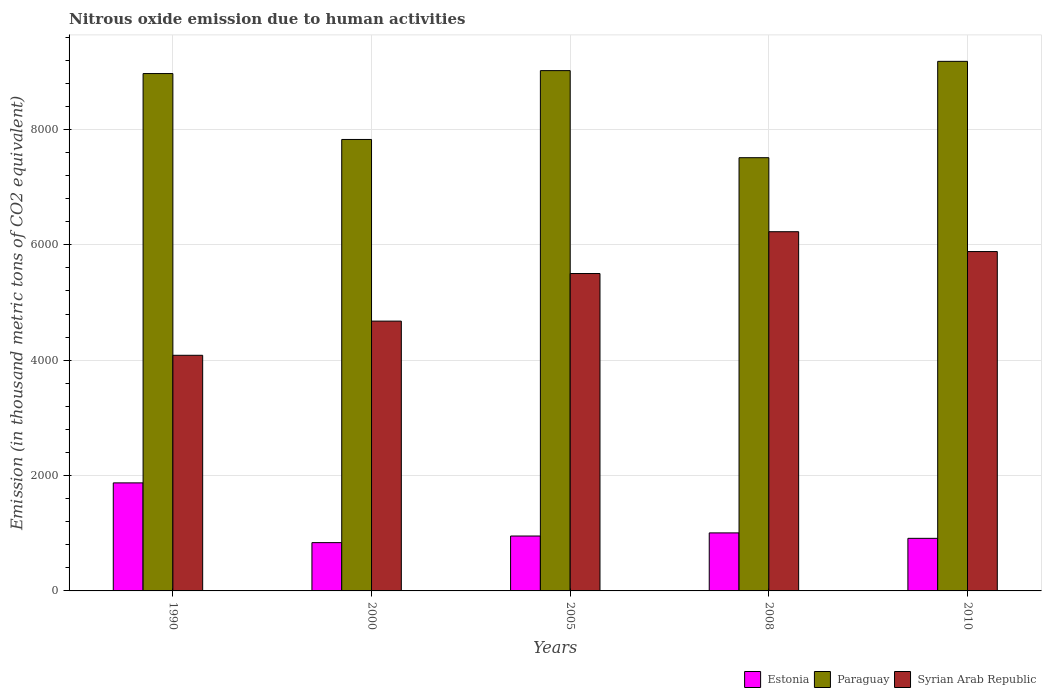How many different coloured bars are there?
Offer a very short reply. 3. How many bars are there on the 3rd tick from the left?
Your response must be concise. 3. How many bars are there on the 2nd tick from the right?
Provide a short and direct response. 3. What is the label of the 3rd group of bars from the left?
Ensure brevity in your answer.  2005. In how many cases, is the number of bars for a given year not equal to the number of legend labels?
Offer a very short reply. 0. What is the amount of nitrous oxide emitted in Syrian Arab Republic in 2000?
Your answer should be compact. 4677.3. Across all years, what is the maximum amount of nitrous oxide emitted in Estonia?
Make the answer very short. 1872.9. Across all years, what is the minimum amount of nitrous oxide emitted in Paraguay?
Your answer should be very brief. 7510.2. In which year was the amount of nitrous oxide emitted in Estonia maximum?
Make the answer very short. 1990. In which year was the amount of nitrous oxide emitted in Estonia minimum?
Provide a short and direct response. 2000. What is the total amount of nitrous oxide emitted in Estonia in the graph?
Offer a terse response. 5579.2. What is the difference between the amount of nitrous oxide emitted in Estonia in 1990 and that in 2000?
Provide a succinct answer. 1035.9. What is the difference between the amount of nitrous oxide emitted in Paraguay in 2008 and the amount of nitrous oxide emitted in Estonia in 1990?
Offer a terse response. 5637.3. What is the average amount of nitrous oxide emitted in Estonia per year?
Provide a succinct answer. 1115.84. In the year 1990, what is the difference between the amount of nitrous oxide emitted in Syrian Arab Republic and amount of nitrous oxide emitted in Estonia?
Your answer should be compact. 2211.9. What is the ratio of the amount of nitrous oxide emitted in Paraguay in 2005 to that in 2008?
Offer a terse response. 1.2. Is the amount of nitrous oxide emitted in Estonia in 2005 less than that in 2010?
Keep it short and to the point. No. What is the difference between the highest and the second highest amount of nitrous oxide emitted in Estonia?
Keep it short and to the point. 867. What is the difference between the highest and the lowest amount of nitrous oxide emitted in Estonia?
Keep it short and to the point. 1035.9. In how many years, is the amount of nitrous oxide emitted in Syrian Arab Republic greater than the average amount of nitrous oxide emitted in Syrian Arab Republic taken over all years?
Your answer should be compact. 3. Is the sum of the amount of nitrous oxide emitted in Paraguay in 2005 and 2008 greater than the maximum amount of nitrous oxide emitted in Syrian Arab Republic across all years?
Provide a succinct answer. Yes. What does the 1st bar from the left in 2005 represents?
Your response must be concise. Estonia. What does the 2nd bar from the right in 1990 represents?
Make the answer very short. Paraguay. How many bars are there?
Ensure brevity in your answer.  15. How many years are there in the graph?
Keep it short and to the point. 5. What is the difference between two consecutive major ticks on the Y-axis?
Your answer should be compact. 2000. Does the graph contain any zero values?
Provide a succinct answer. No. Where does the legend appear in the graph?
Provide a short and direct response. Bottom right. How are the legend labels stacked?
Ensure brevity in your answer.  Horizontal. What is the title of the graph?
Your answer should be compact. Nitrous oxide emission due to human activities. What is the label or title of the Y-axis?
Offer a very short reply. Emission (in thousand metric tons of CO2 equivalent). What is the Emission (in thousand metric tons of CO2 equivalent) of Estonia in 1990?
Give a very brief answer. 1872.9. What is the Emission (in thousand metric tons of CO2 equivalent) of Paraguay in 1990?
Give a very brief answer. 8968.7. What is the Emission (in thousand metric tons of CO2 equivalent) of Syrian Arab Republic in 1990?
Offer a terse response. 4084.8. What is the Emission (in thousand metric tons of CO2 equivalent) of Estonia in 2000?
Provide a short and direct response. 837. What is the Emission (in thousand metric tons of CO2 equivalent) of Paraguay in 2000?
Your answer should be very brief. 7826.3. What is the Emission (in thousand metric tons of CO2 equivalent) of Syrian Arab Republic in 2000?
Your answer should be compact. 4677.3. What is the Emission (in thousand metric tons of CO2 equivalent) of Estonia in 2005?
Your answer should be very brief. 951.7. What is the Emission (in thousand metric tons of CO2 equivalent) of Paraguay in 2005?
Make the answer very short. 9019.7. What is the Emission (in thousand metric tons of CO2 equivalent) in Syrian Arab Republic in 2005?
Offer a terse response. 5502.2. What is the Emission (in thousand metric tons of CO2 equivalent) in Estonia in 2008?
Offer a terse response. 1005.9. What is the Emission (in thousand metric tons of CO2 equivalent) in Paraguay in 2008?
Provide a short and direct response. 7510.2. What is the Emission (in thousand metric tons of CO2 equivalent) in Syrian Arab Republic in 2008?
Offer a very short reply. 6227.1. What is the Emission (in thousand metric tons of CO2 equivalent) of Estonia in 2010?
Make the answer very short. 911.7. What is the Emission (in thousand metric tons of CO2 equivalent) in Paraguay in 2010?
Provide a short and direct response. 9180.3. What is the Emission (in thousand metric tons of CO2 equivalent) of Syrian Arab Republic in 2010?
Your answer should be very brief. 5883.1. Across all years, what is the maximum Emission (in thousand metric tons of CO2 equivalent) of Estonia?
Your answer should be very brief. 1872.9. Across all years, what is the maximum Emission (in thousand metric tons of CO2 equivalent) in Paraguay?
Your response must be concise. 9180.3. Across all years, what is the maximum Emission (in thousand metric tons of CO2 equivalent) in Syrian Arab Republic?
Give a very brief answer. 6227.1. Across all years, what is the minimum Emission (in thousand metric tons of CO2 equivalent) in Estonia?
Your answer should be very brief. 837. Across all years, what is the minimum Emission (in thousand metric tons of CO2 equivalent) of Paraguay?
Your answer should be very brief. 7510.2. Across all years, what is the minimum Emission (in thousand metric tons of CO2 equivalent) of Syrian Arab Republic?
Offer a terse response. 4084.8. What is the total Emission (in thousand metric tons of CO2 equivalent) of Estonia in the graph?
Ensure brevity in your answer.  5579.2. What is the total Emission (in thousand metric tons of CO2 equivalent) in Paraguay in the graph?
Ensure brevity in your answer.  4.25e+04. What is the total Emission (in thousand metric tons of CO2 equivalent) in Syrian Arab Republic in the graph?
Offer a very short reply. 2.64e+04. What is the difference between the Emission (in thousand metric tons of CO2 equivalent) in Estonia in 1990 and that in 2000?
Offer a terse response. 1035.9. What is the difference between the Emission (in thousand metric tons of CO2 equivalent) in Paraguay in 1990 and that in 2000?
Your response must be concise. 1142.4. What is the difference between the Emission (in thousand metric tons of CO2 equivalent) of Syrian Arab Republic in 1990 and that in 2000?
Ensure brevity in your answer.  -592.5. What is the difference between the Emission (in thousand metric tons of CO2 equivalent) in Estonia in 1990 and that in 2005?
Keep it short and to the point. 921.2. What is the difference between the Emission (in thousand metric tons of CO2 equivalent) of Paraguay in 1990 and that in 2005?
Your answer should be very brief. -51. What is the difference between the Emission (in thousand metric tons of CO2 equivalent) in Syrian Arab Republic in 1990 and that in 2005?
Your answer should be compact. -1417.4. What is the difference between the Emission (in thousand metric tons of CO2 equivalent) in Estonia in 1990 and that in 2008?
Your response must be concise. 867. What is the difference between the Emission (in thousand metric tons of CO2 equivalent) of Paraguay in 1990 and that in 2008?
Ensure brevity in your answer.  1458.5. What is the difference between the Emission (in thousand metric tons of CO2 equivalent) of Syrian Arab Republic in 1990 and that in 2008?
Provide a succinct answer. -2142.3. What is the difference between the Emission (in thousand metric tons of CO2 equivalent) of Estonia in 1990 and that in 2010?
Provide a succinct answer. 961.2. What is the difference between the Emission (in thousand metric tons of CO2 equivalent) in Paraguay in 1990 and that in 2010?
Your answer should be compact. -211.6. What is the difference between the Emission (in thousand metric tons of CO2 equivalent) in Syrian Arab Republic in 1990 and that in 2010?
Make the answer very short. -1798.3. What is the difference between the Emission (in thousand metric tons of CO2 equivalent) of Estonia in 2000 and that in 2005?
Make the answer very short. -114.7. What is the difference between the Emission (in thousand metric tons of CO2 equivalent) of Paraguay in 2000 and that in 2005?
Offer a terse response. -1193.4. What is the difference between the Emission (in thousand metric tons of CO2 equivalent) of Syrian Arab Republic in 2000 and that in 2005?
Provide a short and direct response. -824.9. What is the difference between the Emission (in thousand metric tons of CO2 equivalent) of Estonia in 2000 and that in 2008?
Ensure brevity in your answer.  -168.9. What is the difference between the Emission (in thousand metric tons of CO2 equivalent) in Paraguay in 2000 and that in 2008?
Give a very brief answer. 316.1. What is the difference between the Emission (in thousand metric tons of CO2 equivalent) of Syrian Arab Republic in 2000 and that in 2008?
Provide a succinct answer. -1549.8. What is the difference between the Emission (in thousand metric tons of CO2 equivalent) of Estonia in 2000 and that in 2010?
Your answer should be compact. -74.7. What is the difference between the Emission (in thousand metric tons of CO2 equivalent) in Paraguay in 2000 and that in 2010?
Offer a very short reply. -1354. What is the difference between the Emission (in thousand metric tons of CO2 equivalent) in Syrian Arab Republic in 2000 and that in 2010?
Provide a succinct answer. -1205.8. What is the difference between the Emission (in thousand metric tons of CO2 equivalent) of Estonia in 2005 and that in 2008?
Keep it short and to the point. -54.2. What is the difference between the Emission (in thousand metric tons of CO2 equivalent) in Paraguay in 2005 and that in 2008?
Your answer should be compact. 1509.5. What is the difference between the Emission (in thousand metric tons of CO2 equivalent) in Syrian Arab Republic in 2005 and that in 2008?
Your answer should be compact. -724.9. What is the difference between the Emission (in thousand metric tons of CO2 equivalent) in Estonia in 2005 and that in 2010?
Provide a short and direct response. 40. What is the difference between the Emission (in thousand metric tons of CO2 equivalent) of Paraguay in 2005 and that in 2010?
Offer a very short reply. -160.6. What is the difference between the Emission (in thousand metric tons of CO2 equivalent) in Syrian Arab Republic in 2005 and that in 2010?
Provide a succinct answer. -380.9. What is the difference between the Emission (in thousand metric tons of CO2 equivalent) in Estonia in 2008 and that in 2010?
Offer a terse response. 94.2. What is the difference between the Emission (in thousand metric tons of CO2 equivalent) in Paraguay in 2008 and that in 2010?
Your answer should be very brief. -1670.1. What is the difference between the Emission (in thousand metric tons of CO2 equivalent) in Syrian Arab Republic in 2008 and that in 2010?
Offer a terse response. 344. What is the difference between the Emission (in thousand metric tons of CO2 equivalent) of Estonia in 1990 and the Emission (in thousand metric tons of CO2 equivalent) of Paraguay in 2000?
Provide a short and direct response. -5953.4. What is the difference between the Emission (in thousand metric tons of CO2 equivalent) of Estonia in 1990 and the Emission (in thousand metric tons of CO2 equivalent) of Syrian Arab Republic in 2000?
Your answer should be very brief. -2804.4. What is the difference between the Emission (in thousand metric tons of CO2 equivalent) in Paraguay in 1990 and the Emission (in thousand metric tons of CO2 equivalent) in Syrian Arab Republic in 2000?
Provide a succinct answer. 4291.4. What is the difference between the Emission (in thousand metric tons of CO2 equivalent) in Estonia in 1990 and the Emission (in thousand metric tons of CO2 equivalent) in Paraguay in 2005?
Your response must be concise. -7146.8. What is the difference between the Emission (in thousand metric tons of CO2 equivalent) of Estonia in 1990 and the Emission (in thousand metric tons of CO2 equivalent) of Syrian Arab Republic in 2005?
Your response must be concise. -3629.3. What is the difference between the Emission (in thousand metric tons of CO2 equivalent) in Paraguay in 1990 and the Emission (in thousand metric tons of CO2 equivalent) in Syrian Arab Republic in 2005?
Offer a terse response. 3466.5. What is the difference between the Emission (in thousand metric tons of CO2 equivalent) of Estonia in 1990 and the Emission (in thousand metric tons of CO2 equivalent) of Paraguay in 2008?
Offer a very short reply. -5637.3. What is the difference between the Emission (in thousand metric tons of CO2 equivalent) in Estonia in 1990 and the Emission (in thousand metric tons of CO2 equivalent) in Syrian Arab Republic in 2008?
Provide a succinct answer. -4354.2. What is the difference between the Emission (in thousand metric tons of CO2 equivalent) of Paraguay in 1990 and the Emission (in thousand metric tons of CO2 equivalent) of Syrian Arab Republic in 2008?
Provide a short and direct response. 2741.6. What is the difference between the Emission (in thousand metric tons of CO2 equivalent) of Estonia in 1990 and the Emission (in thousand metric tons of CO2 equivalent) of Paraguay in 2010?
Provide a short and direct response. -7307.4. What is the difference between the Emission (in thousand metric tons of CO2 equivalent) in Estonia in 1990 and the Emission (in thousand metric tons of CO2 equivalent) in Syrian Arab Republic in 2010?
Keep it short and to the point. -4010.2. What is the difference between the Emission (in thousand metric tons of CO2 equivalent) of Paraguay in 1990 and the Emission (in thousand metric tons of CO2 equivalent) of Syrian Arab Republic in 2010?
Ensure brevity in your answer.  3085.6. What is the difference between the Emission (in thousand metric tons of CO2 equivalent) of Estonia in 2000 and the Emission (in thousand metric tons of CO2 equivalent) of Paraguay in 2005?
Your answer should be compact. -8182.7. What is the difference between the Emission (in thousand metric tons of CO2 equivalent) in Estonia in 2000 and the Emission (in thousand metric tons of CO2 equivalent) in Syrian Arab Republic in 2005?
Keep it short and to the point. -4665.2. What is the difference between the Emission (in thousand metric tons of CO2 equivalent) in Paraguay in 2000 and the Emission (in thousand metric tons of CO2 equivalent) in Syrian Arab Republic in 2005?
Give a very brief answer. 2324.1. What is the difference between the Emission (in thousand metric tons of CO2 equivalent) in Estonia in 2000 and the Emission (in thousand metric tons of CO2 equivalent) in Paraguay in 2008?
Ensure brevity in your answer.  -6673.2. What is the difference between the Emission (in thousand metric tons of CO2 equivalent) in Estonia in 2000 and the Emission (in thousand metric tons of CO2 equivalent) in Syrian Arab Republic in 2008?
Keep it short and to the point. -5390.1. What is the difference between the Emission (in thousand metric tons of CO2 equivalent) of Paraguay in 2000 and the Emission (in thousand metric tons of CO2 equivalent) of Syrian Arab Republic in 2008?
Provide a short and direct response. 1599.2. What is the difference between the Emission (in thousand metric tons of CO2 equivalent) in Estonia in 2000 and the Emission (in thousand metric tons of CO2 equivalent) in Paraguay in 2010?
Give a very brief answer. -8343.3. What is the difference between the Emission (in thousand metric tons of CO2 equivalent) in Estonia in 2000 and the Emission (in thousand metric tons of CO2 equivalent) in Syrian Arab Republic in 2010?
Your answer should be compact. -5046.1. What is the difference between the Emission (in thousand metric tons of CO2 equivalent) of Paraguay in 2000 and the Emission (in thousand metric tons of CO2 equivalent) of Syrian Arab Republic in 2010?
Your answer should be very brief. 1943.2. What is the difference between the Emission (in thousand metric tons of CO2 equivalent) of Estonia in 2005 and the Emission (in thousand metric tons of CO2 equivalent) of Paraguay in 2008?
Offer a terse response. -6558.5. What is the difference between the Emission (in thousand metric tons of CO2 equivalent) in Estonia in 2005 and the Emission (in thousand metric tons of CO2 equivalent) in Syrian Arab Republic in 2008?
Keep it short and to the point. -5275.4. What is the difference between the Emission (in thousand metric tons of CO2 equivalent) in Paraguay in 2005 and the Emission (in thousand metric tons of CO2 equivalent) in Syrian Arab Republic in 2008?
Your answer should be compact. 2792.6. What is the difference between the Emission (in thousand metric tons of CO2 equivalent) of Estonia in 2005 and the Emission (in thousand metric tons of CO2 equivalent) of Paraguay in 2010?
Offer a very short reply. -8228.6. What is the difference between the Emission (in thousand metric tons of CO2 equivalent) in Estonia in 2005 and the Emission (in thousand metric tons of CO2 equivalent) in Syrian Arab Republic in 2010?
Give a very brief answer. -4931.4. What is the difference between the Emission (in thousand metric tons of CO2 equivalent) of Paraguay in 2005 and the Emission (in thousand metric tons of CO2 equivalent) of Syrian Arab Republic in 2010?
Offer a terse response. 3136.6. What is the difference between the Emission (in thousand metric tons of CO2 equivalent) of Estonia in 2008 and the Emission (in thousand metric tons of CO2 equivalent) of Paraguay in 2010?
Provide a short and direct response. -8174.4. What is the difference between the Emission (in thousand metric tons of CO2 equivalent) of Estonia in 2008 and the Emission (in thousand metric tons of CO2 equivalent) of Syrian Arab Republic in 2010?
Your answer should be very brief. -4877.2. What is the difference between the Emission (in thousand metric tons of CO2 equivalent) in Paraguay in 2008 and the Emission (in thousand metric tons of CO2 equivalent) in Syrian Arab Republic in 2010?
Offer a very short reply. 1627.1. What is the average Emission (in thousand metric tons of CO2 equivalent) of Estonia per year?
Make the answer very short. 1115.84. What is the average Emission (in thousand metric tons of CO2 equivalent) in Paraguay per year?
Offer a terse response. 8501.04. What is the average Emission (in thousand metric tons of CO2 equivalent) in Syrian Arab Republic per year?
Your response must be concise. 5274.9. In the year 1990, what is the difference between the Emission (in thousand metric tons of CO2 equivalent) of Estonia and Emission (in thousand metric tons of CO2 equivalent) of Paraguay?
Your answer should be compact. -7095.8. In the year 1990, what is the difference between the Emission (in thousand metric tons of CO2 equivalent) of Estonia and Emission (in thousand metric tons of CO2 equivalent) of Syrian Arab Republic?
Keep it short and to the point. -2211.9. In the year 1990, what is the difference between the Emission (in thousand metric tons of CO2 equivalent) in Paraguay and Emission (in thousand metric tons of CO2 equivalent) in Syrian Arab Republic?
Offer a terse response. 4883.9. In the year 2000, what is the difference between the Emission (in thousand metric tons of CO2 equivalent) in Estonia and Emission (in thousand metric tons of CO2 equivalent) in Paraguay?
Give a very brief answer. -6989.3. In the year 2000, what is the difference between the Emission (in thousand metric tons of CO2 equivalent) of Estonia and Emission (in thousand metric tons of CO2 equivalent) of Syrian Arab Republic?
Your response must be concise. -3840.3. In the year 2000, what is the difference between the Emission (in thousand metric tons of CO2 equivalent) of Paraguay and Emission (in thousand metric tons of CO2 equivalent) of Syrian Arab Republic?
Provide a short and direct response. 3149. In the year 2005, what is the difference between the Emission (in thousand metric tons of CO2 equivalent) of Estonia and Emission (in thousand metric tons of CO2 equivalent) of Paraguay?
Offer a terse response. -8068. In the year 2005, what is the difference between the Emission (in thousand metric tons of CO2 equivalent) of Estonia and Emission (in thousand metric tons of CO2 equivalent) of Syrian Arab Republic?
Your answer should be very brief. -4550.5. In the year 2005, what is the difference between the Emission (in thousand metric tons of CO2 equivalent) in Paraguay and Emission (in thousand metric tons of CO2 equivalent) in Syrian Arab Republic?
Make the answer very short. 3517.5. In the year 2008, what is the difference between the Emission (in thousand metric tons of CO2 equivalent) of Estonia and Emission (in thousand metric tons of CO2 equivalent) of Paraguay?
Your answer should be compact. -6504.3. In the year 2008, what is the difference between the Emission (in thousand metric tons of CO2 equivalent) of Estonia and Emission (in thousand metric tons of CO2 equivalent) of Syrian Arab Republic?
Your answer should be compact. -5221.2. In the year 2008, what is the difference between the Emission (in thousand metric tons of CO2 equivalent) in Paraguay and Emission (in thousand metric tons of CO2 equivalent) in Syrian Arab Republic?
Ensure brevity in your answer.  1283.1. In the year 2010, what is the difference between the Emission (in thousand metric tons of CO2 equivalent) in Estonia and Emission (in thousand metric tons of CO2 equivalent) in Paraguay?
Give a very brief answer. -8268.6. In the year 2010, what is the difference between the Emission (in thousand metric tons of CO2 equivalent) in Estonia and Emission (in thousand metric tons of CO2 equivalent) in Syrian Arab Republic?
Your answer should be very brief. -4971.4. In the year 2010, what is the difference between the Emission (in thousand metric tons of CO2 equivalent) in Paraguay and Emission (in thousand metric tons of CO2 equivalent) in Syrian Arab Republic?
Ensure brevity in your answer.  3297.2. What is the ratio of the Emission (in thousand metric tons of CO2 equivalent) in Estonia in 1990 to that in 2000?
Provide a succinct answer. 2.24. What is the ratio of the Emission (in thousand metric tons of CO2 equivalent) in Paraguay in 1990 to that in 2000?
Ensure brevity in your answer.  1.15. What is the ratio of the Emission (in thousand metric tons of CO2 equivalent) in Syrian Arab Republic in 1990 to that in 2000?
Your response must be concise. 0.87. What is the ratio of the Emission (in thousand metric tons of CO2 equivalent) of Estonia in 1990 to that in 2005?
Offer a very short reply. 1.97. What is the ratio of the Emission (in thousand metric tons of CO2 equivalent) of Syrian Arab Republic in 1990 to that in 2005?
Your answer should be very brief. 0.74. What is the ratio of the Emission (in thousand metric tons of CO2 equivalent) of Estonia in 1990 to that in 2008?
Provide a succinct answer. 1.86. What is the ratio of the Emission (in thousand metric tons of CO2 equivalent) in Paraguay in 1990 to that in 2008?
Provide a short and direct response. 1.19. What is the ratio of the Emission (in thousand metric tons of CO2 equivalent) in Syrian Arab Republic in 1990 to that in 2008?
Keep it short and to the point. 0.66. What is the ratio of the Emission (in thousand metric tons of CO2 equivalent) of Estonia in 1990 to that in 2010?
Your response must be concise. 2.05. What is the ratio of the Emission (in thousand metric tons of CO2 equivalent) in Paraguay in 1990 to that in 2010?
Ensure brevity in your answer.  0.98. What is the ratio of the Emission (in thousand metric tons of CO2 equivalent) in Syrian Arab Republic in 1990 to that in 2010?
Give a very brief answer. 0.69. What is the ratio of the Emission (in thousand metric tons of CO2 equivalent) of Estonia in 2000 to that in 2005?
Provide a short and direct response. 0.88. What is the ratio of the Emission (in thousand metric tons of CO2 equivalent) in Paraguay in 2000 to that in 2005?
Give a very brief answer. 0.87. What is the ratio of the Emission (in thousand metric tons of CO2 equivalent) in Syrian Arab Republic in 2000 to that in 2005?
Your response must be concise. 0.85. What is the ratio of the Emission (in thousand metric tons of CO2 equivalent) in Estonia in 2000 to that in 2008?
Offer a terse response. 0.83. What is the ratio of the Emission (in thousand metric tons of CO2 equivalent) of Paraguay in 2000 to that in 2008?
Provide a short and direct response. 1.04. What is the ratio of the Emission (in thousand metric tons of CO2 equivalent) of Syrian Arab Republic in 2000 to that in 2008?
Provide a short and direct response. 0.75. What is the ratio of the Emission (in thousand metric tons of CO2 equivalent) in Estonia in 2000 to that in 2010?
Offer a terse response. 0.92. What is the ratio of the Emission (in thousand metric tons of CO2 equivalent) in Paraguay in 2000 to that in 2010?
Provide a succinct answer. 0.85. What is the ratio of the Emission (in thousand metric tons of CO2 equivalent) of Syrian Arab Republic in 2000 to that in 2010?
Offer a terse response. 0.8. What is the ratio of the Emission (in thousand metric tons of CO2 equivalent) in Estonia in 2005 to that in 2008?
Offer a very short reply. 0.95. What is the ratio of the Emission (in thousand metric tons of CO2 equivalent) of Paraguay in 2005 to that in 2008?
Your answer should be compact. 1.2. What is the ratio of the Emission (in thousand metric tons of CO2 equivalent) of Syrian Arab Republic in 2005 to that in 2008?
Give a very brief answer. 0.88. What is the ratio of the Emission (in thousand metric tons of CO2 equivalent) of Estonia in 2005 to that in 2010?
Offer a very short reply. 1.04. What is the ratio of the Emission (in thousand metric tons of CO2 equivalent) of Paraguay in 2005 to that in 2010?
Make the answer very short. 0.98. What is the ratio of the Emission (in thousand metric tons of CO2 equivalent) of Syrian Arab Republic in 2005 to that in 2010?
Ensure brevity in your answer.  0.94. What is the ratio of the Emission (in thousand metric tons of CO2 equivalent) of Estonia in 2008 to that in 2010?
Provide a short and direct response. 1.1. What is the ratio of the Emission (in thousand metric tons of CO2 equivalent) of Paraguay in 2008 to that in 2010?
Give a very brief answer. 0.82. What is the ratio of the Emission (in thousand metric tons of CO2 equivalent) of Syrian Arab Republic in 2008 to that in 2010?
Offer a terse response. 1.06. What is the difference between the highest and the second highest Emission (in thousand metric tons of CO2 equivalent) in Estonia?
Your answer should be very brief. 867. What is the difference between the highest and the second highest Emission (in thousand metric tons of CO2 equivalent) of Paraguay?
Keep it short and to the point. 160.6. What is the difference between the highest and the second highest Emission (in thousand metric tons of CO2 equivalent) of Syrian Arab Republic?
Your answer should be very brief. 344. What is the difference between the highest and the lowest Emission (in thousand metric tons of CO2 equivalent) of Estonia?
Your answer should be very brief. 1035.9. What is the difference between the highest and the lowest Emission (in thousand metric tons of CO2 equivalent) of Paraguay?
Provide a short and direct response. 1670.1. What is the difference between the highest and the lowest Emission (in thousand metric tons of CO2 equivalent) in Syrian Arab Republic?
Offer a terse response. 2142.3. 